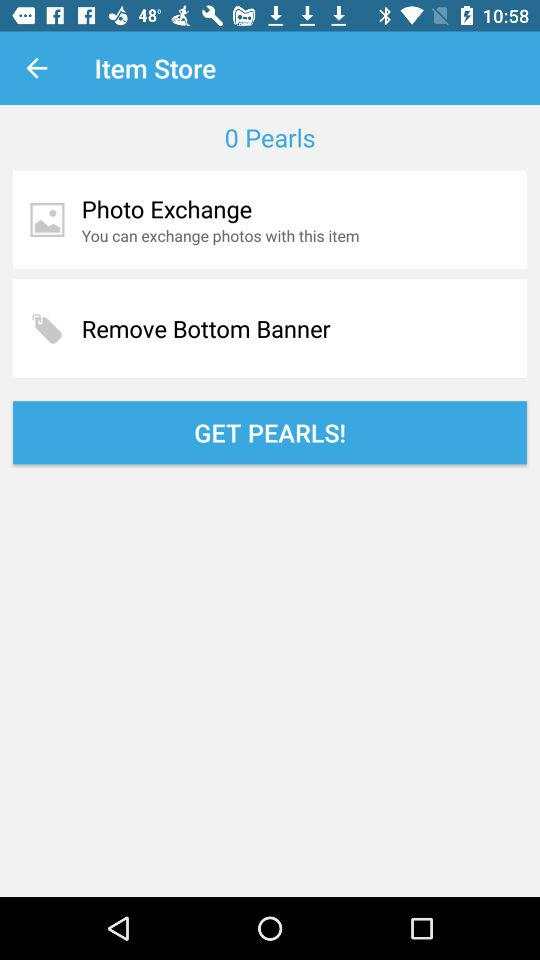How many pearls are there? There are 0 pearls. 